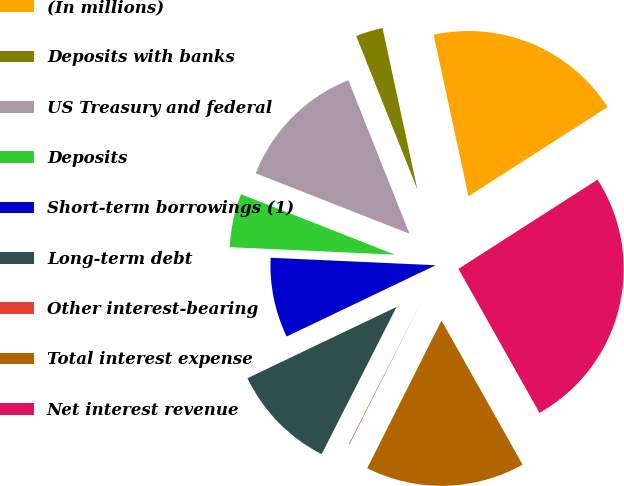Convert chart. <chart><loc_0><loc_0><loc_500><loc_500><pie_chart><fcel>(In millions)<fcel>Deposits with banks<fcel>US Treasury and federal<fcel>Deposits<fcel>Short-term borrowings (1)<fcel>Long-term debt<fcel>Other interest-bearing<fcel>Total interest expense<fcel>Net interest revenue<nl><fcel>19.31%<fcel>2.65%<fcel>13.0%<fcel>5.24%<fcel>7.82%<fcel>10.41%<fcel>0.07%<fcel>15.58%<fcel>25.92%<nl></chart> 